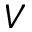<formula> <loc_0><loc_0><loc_500><loc_500>V</formula> 